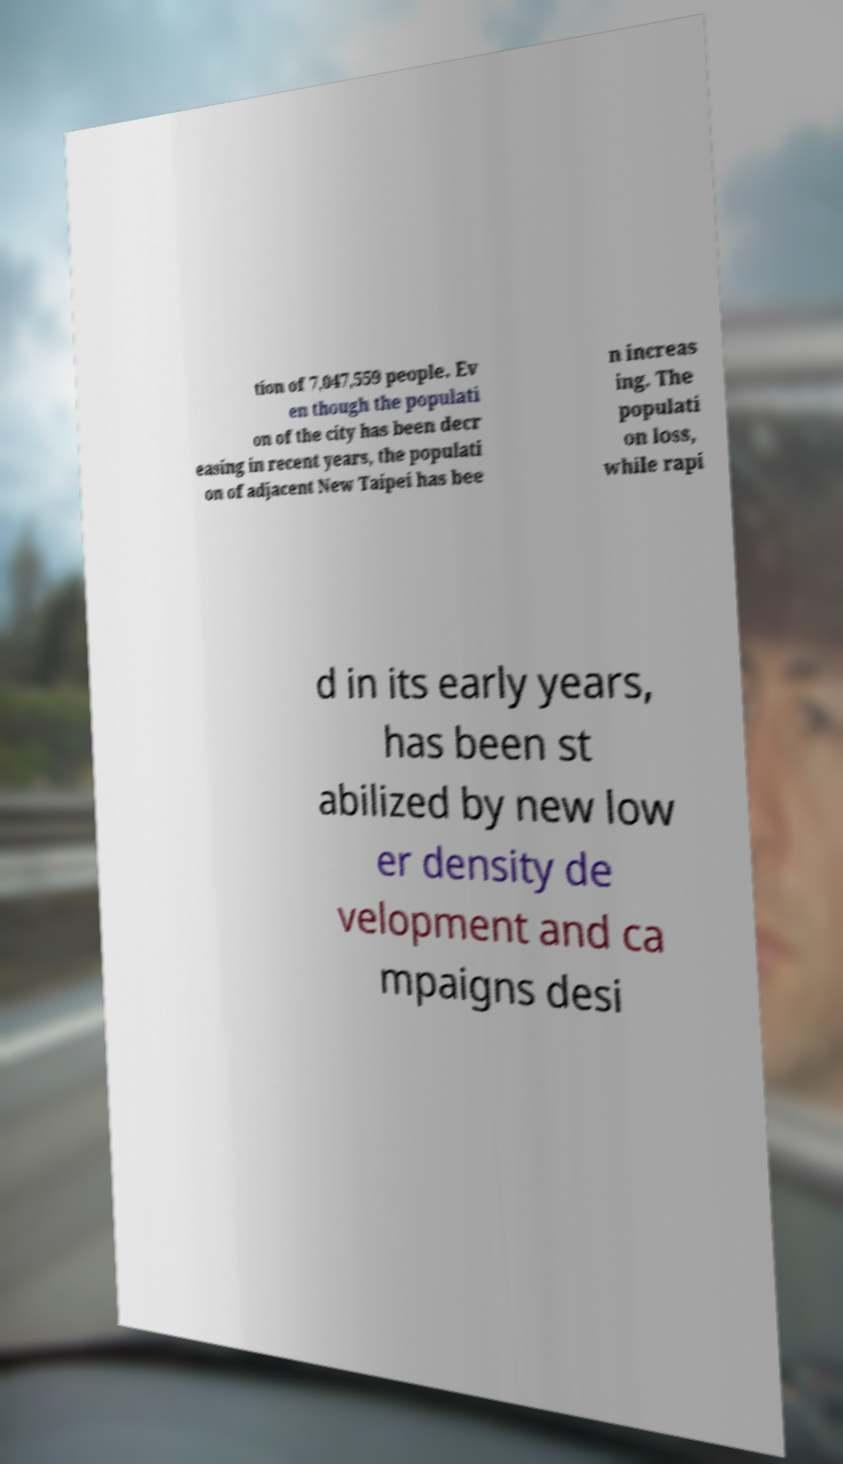There's text embedded in this image that I need extracted. Can you transcribe it verbatim? tion of 7,047,559 people. Ev en though the populati on of the city has been decr easing in recent years, the populati on of adjacent New Taipei has bee n increas ing. The populati on loss, while rapi d in its early years, has been st abilized by new low er density de velopment and ca mpaigns desi 